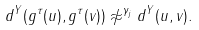Convert formula to latex. <formula><loc_0><loc_0><loc_500><loc_500>d ^ { Y } ( g ^ { \tau } ( u ) , g ^ { \tau } ( v ) ) \not \approx ^ { \gamma _ { j } } d ^ { Y } ( u , v ) .</formula> 